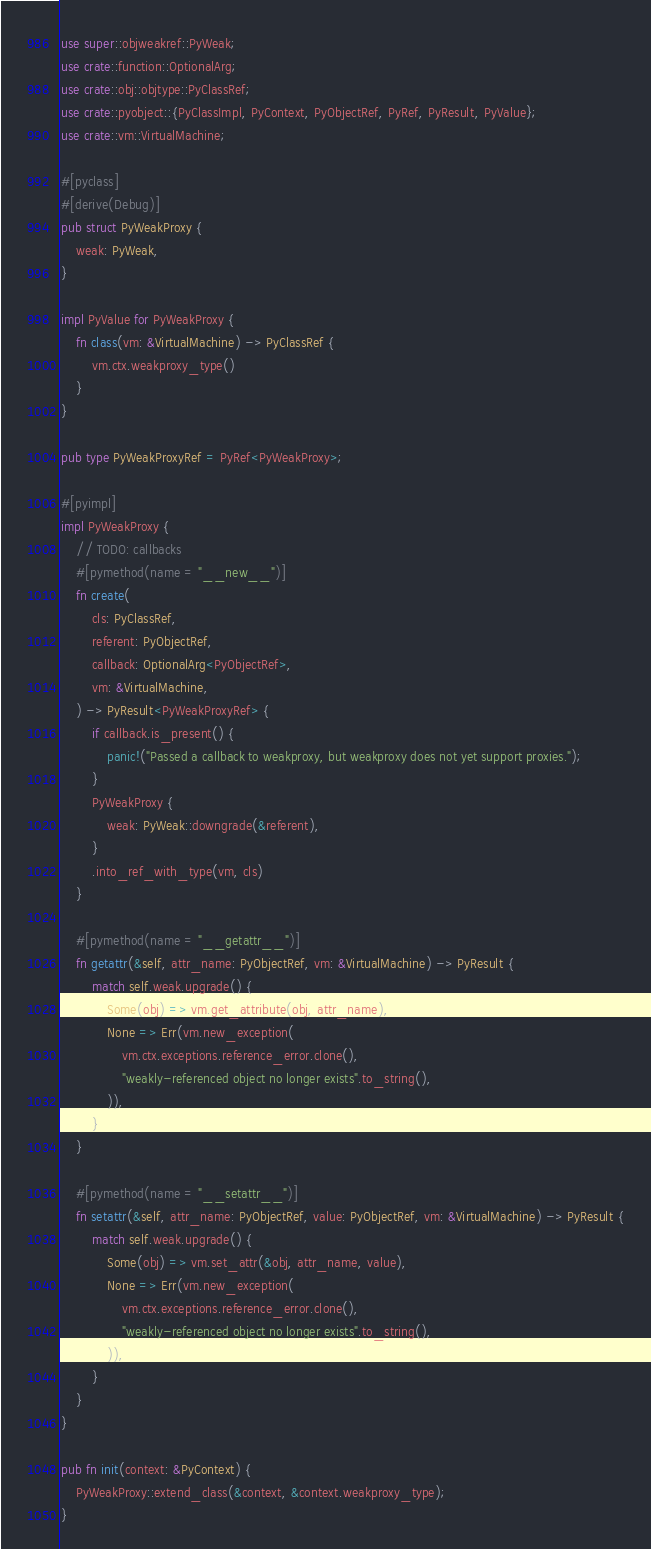Convert code to text. <code><loc_0><loc_0><loc_500><loc_500><_Rust_>use super::objweakref::PyWeak;
use crate::function::OptionalArg;
use crate::obj::objtype::PyClassRef;
use crate::pyobject::{PyClassImpl, PyContext, PyObjectRef, PyRef, PyResult, PyValue};
use crate::vm::VirtualMachine;

#[pyclass]
#[derive(Debug)]
pub struct PyWeakProxy {
    weak: PyWeak,
}

impl PyValue for PyWeakProxy {
    fn class(vm: &VirtualMachine) -> PyClassRef {
        vm.ctx.weakproxy_type()
    }
}

pub type PyWeakProxyRef = PyRef<PyWeakProxy>;

#[pyimpl]
impl PyWeakProxy {
    // TODO: callbacks
    #[pymethod(name = "__new__")]
    fn create(
        cls: PyClassRef,
        referent: PyObjectRef,
        callback: OptionalArg<PyObjectRef>,
        vm: &VirtualMachine,
    ) -> PyResult<PyWeakProxyRef> {
        if callback.is_present() {
            panic!("Passed a callback to weakproxy, but weakproxy does not yet support proxies.");
        }
        PyWeakProxy {
            weak: PyWeak::downgrade(&referent),
        }
        .into_ref_with_type(vm, cls)
    }

    #[pymethod(name = "__getattr__")]
    fn getattr(&self, attr_name: PyObjectRef, vm: &VirtualMachine) -> PyResult {
        match self.weak.upgrade() {
            Some(obj) => vm.get_attribute(obj, attr_name),
            None => Err(vm.new_exception(
                vm.ctx.exceptions.reference_error.clone(),
                "weakly-referenced object no longer exists".to_string(),
            )),
        }
    }

    #[pymethod(name = "__setattr__")]
    fn setattr(&self, attr_name: PyObjectRef, value: PyObjectRef, vm: &VirtualMachine) -> PyResult {
        match self.weak.upgrade() {
            Some(obj) => vm.set_attr(&obj, attr_name, value),
            None => Err(vm.new_exception(
                vm.ctx.exceptions.reference_error.clone(),
                "weakly-referenced object no longer exists".to_string(),
            )),
        }
    }
}

pub fn init(context: &PyContext) {
    PyWeakProxy::extend_class(&context, &context.weakproxy_type);
}
</code> 